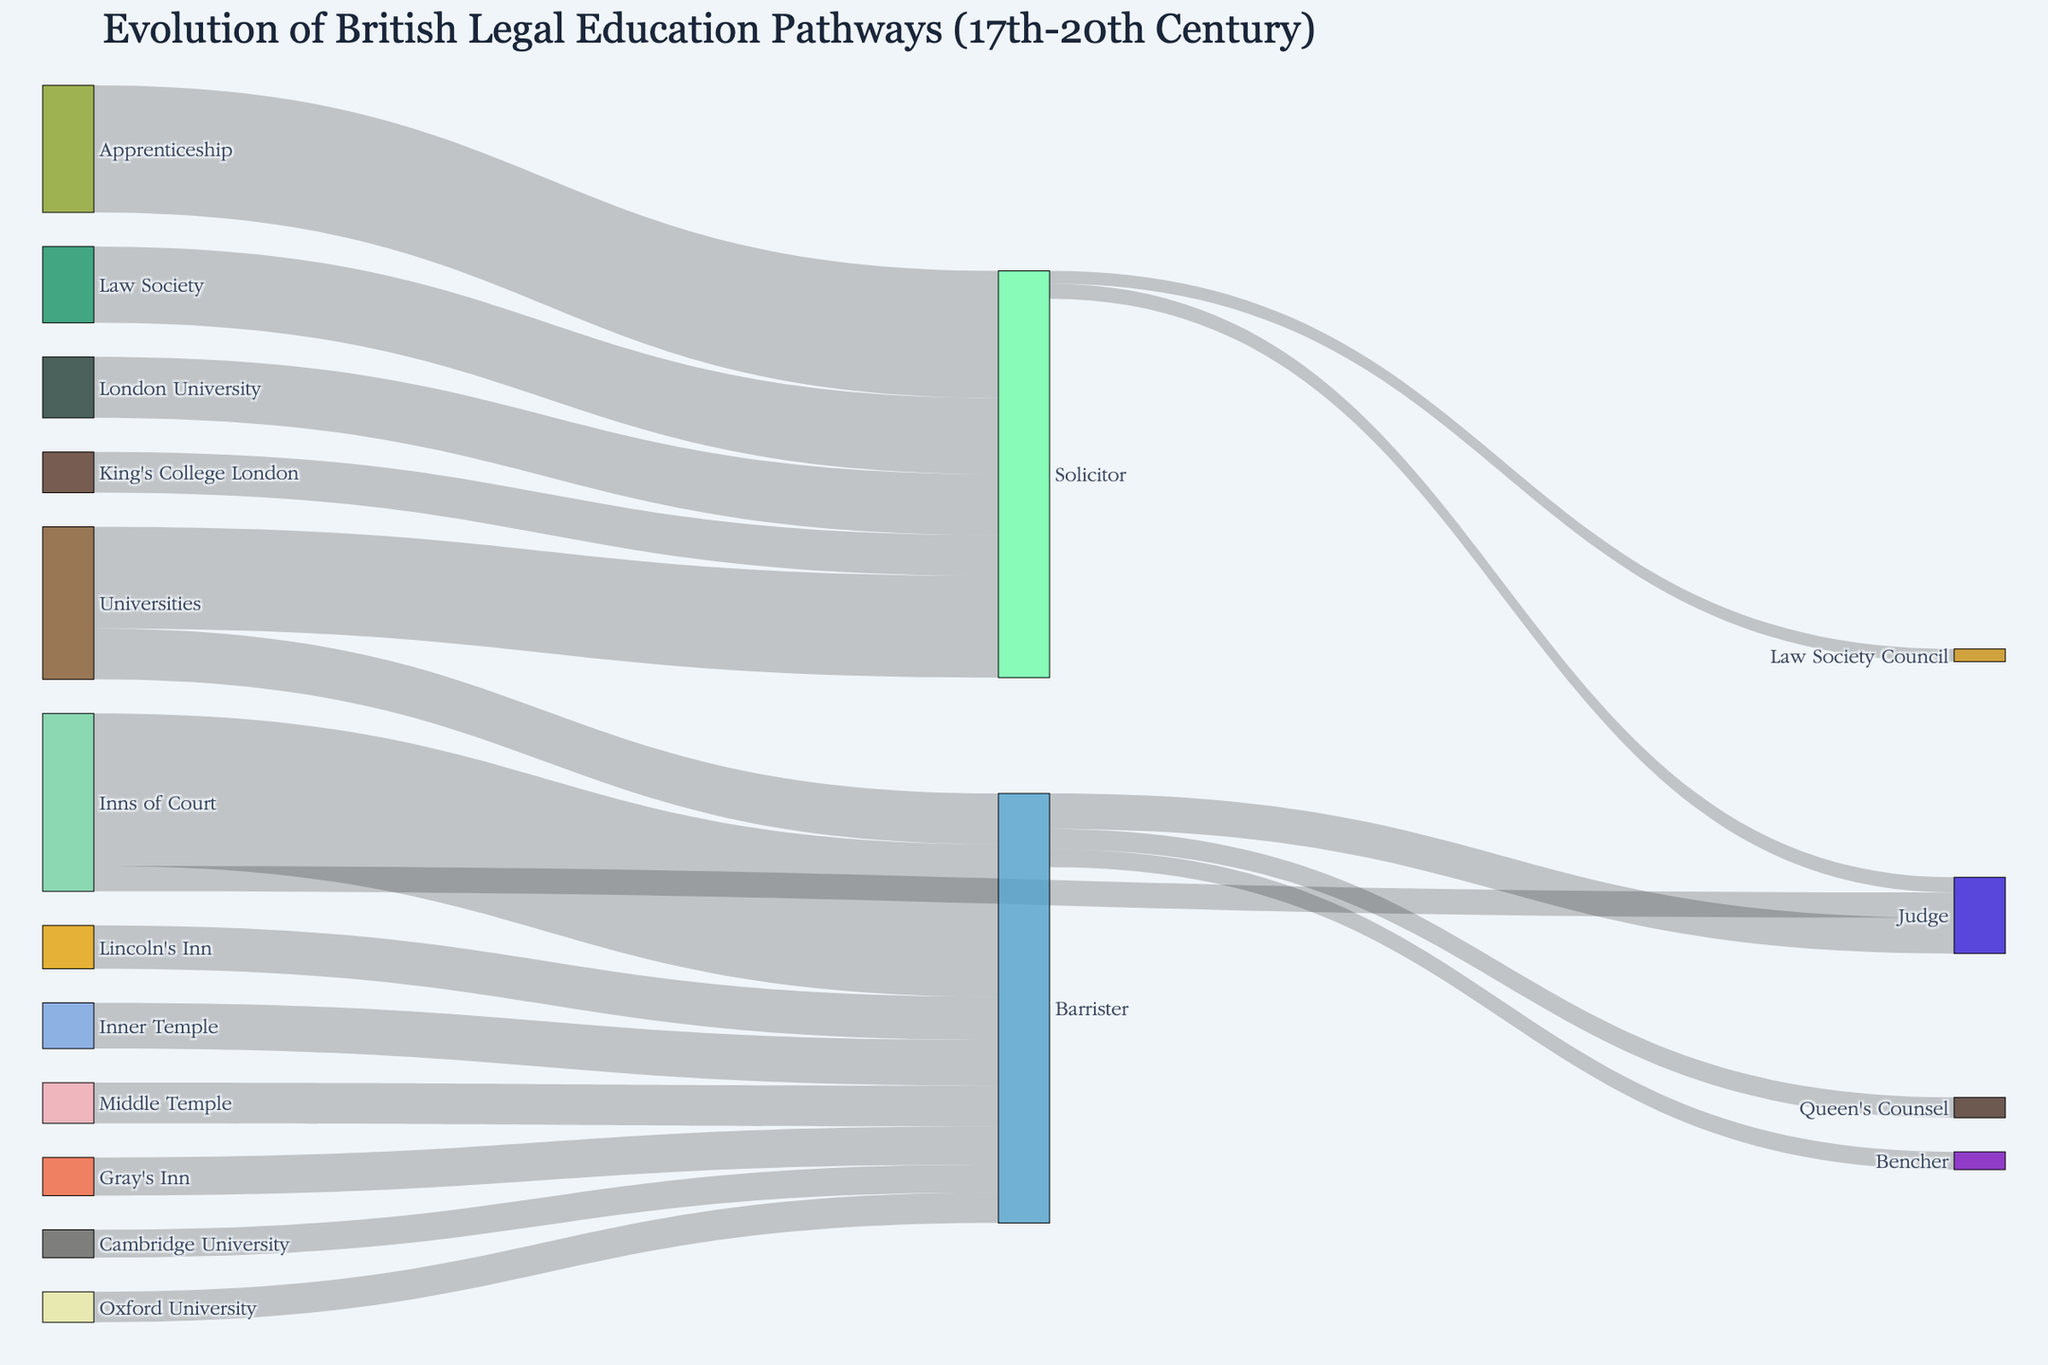What is the title of the Sankey diagram? The title is mentioned at the top of the diagram. It provides an overview of the figure's content.
Answer: Evolution of British Legal Education Pathways (17th-20th Century) How many pathways are flowing into the 'Barrister' node? Count all the links or flows that have 'Barrister' as their target.
Answer: 8 Which pathway has the highest value flowing into the 'Solicitor' node? Compare the values of all pathways flowing into 'Solicitor' and identify the highest one.
Answer: Apprenticeship → Solicitor (250) What is the combined value of all pathways from the 'Inns of Court' node? Sum up all the values of pathways that have 'Inns of Court' as their source.
Answer: 350 Compare the values flowing from 'Universities' to 'Solicitor' and 'Inns of Court' to 'Judge'. Which is higher and by how much? Identify the values for both pathways and calculate the difference. (200 from Universities to Solicitor vs. 50 from Inns of Court to Judge).
Answer: Universities → Solicitor is higher by 150 What is the total value flowing from 'Barrister' to other nodes? Add up all the values of pathways that have 'Barrister' as their source.
Answer: 145 Which university contributes the least to the 'Barrister' node? Compare contributions from 'Oxford University', 'Cambridge University', and 'London University' to 'Barrister' and find the smallest value.
Answer: Cambridge University (55) What is the percentage of pathways from 'Law Society' leading to 'Solicitor' compared to total pathways leading to 'Solicitor'? Sum the values of pathways to 'Solicitor', then calculate the percentage contributed by 'Law Society'.
Answer: (150 / (200 + 250 + 150 + 120 + 80)) x 100 = 16.13% How many pathways are directly leading to the 'Judge' node? Count the number of links that have 'Judge' as their target.
Answer: 3 Which has more connections flowing into it: 'Barrister' or 'Solicitor'? Count the number of incoming pathways for both 'Barrister' and 'Solicitor'.
Answer: Barrister (8) 